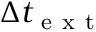Convert formula to latex. <formula><loc_0><loc_0><loc_500><loc_500>\Delta t _ { e x t }</formula> 